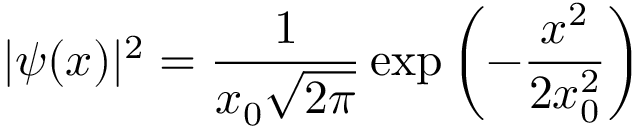Convert formula to latex. <formula><loc_0><loc_0><loc_500><loc_500>| \psi ( x ) | ^ { 2 } = { \frac { 1 } { x _ { 0 } { \sqrt { 2 \pi } } } } \exp { \left ( - { \frac { x ^ { 2 } } { 2 x _ { 0 } ^ { 2 } } } \right ) }</formula> 